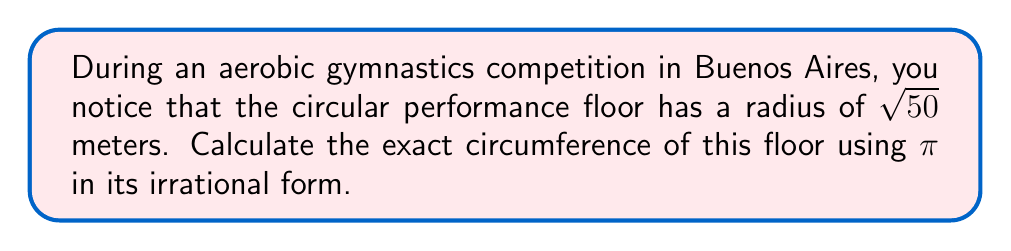Solve this math problem. To solve this problem, we'll follow these steps:

1) Recall the formula for the circumference of a circle:
   $$C = 2\pi r$$
   where $C$ is the circumference and $r$ is the radius.

2) We're given that the radius $r = \sqrt{50}$ meters.

3) Substitute this into our formula:
   $$C = 2\pi \sqrt{50}$$

4) Simplify $\sqrt{50}$:
   $$\sqrt{50} = \sqrt{25 \cdot 2} = 5\sqrt{2}$$

5) Substitute this back into our equation:
   $$C = 2\pi (5\sqrt{2})$$

6) Simplify:
   $$C = 10\pi\sqrt{2}$$

This is our final answer in exact form, using $\pi$ as an irrational number.

[asy]
unitsize(1cm);
draw(circle((0,0),5), blue);
draw((0,0)--(5,0), red, Arrow);
label("$5\sqrt{2}$", (2.5,0), S);
label("Gymnastics Floor", (0,-6));
[/asy]
Answer: $10\pi\sqrt{2}$ meters 